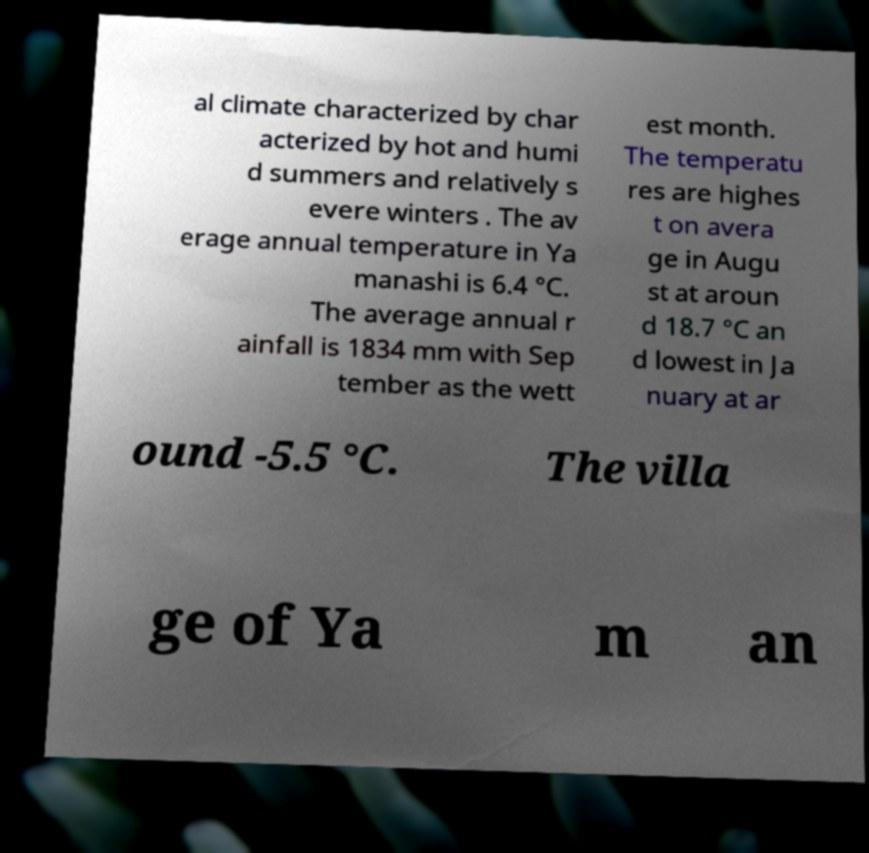Can you read and provide the text displayed in the image?This photo seems to have some interesting text. Can you extract and type it out for me? al climate characterized by char acterized by hot and humi d summers and relatively s evere winters . The av erage annual temperature in Ya manashi is 6.4 °C. The average annual r ainfall is 1834 mm with Sep tember as the wett est month. The temperatu res are highes t on avera ge in Augu st at aroun d 18.7 °C an d lowest in Ja nuary at ar ound -5.5 °C. The villa ge of Ya m an 